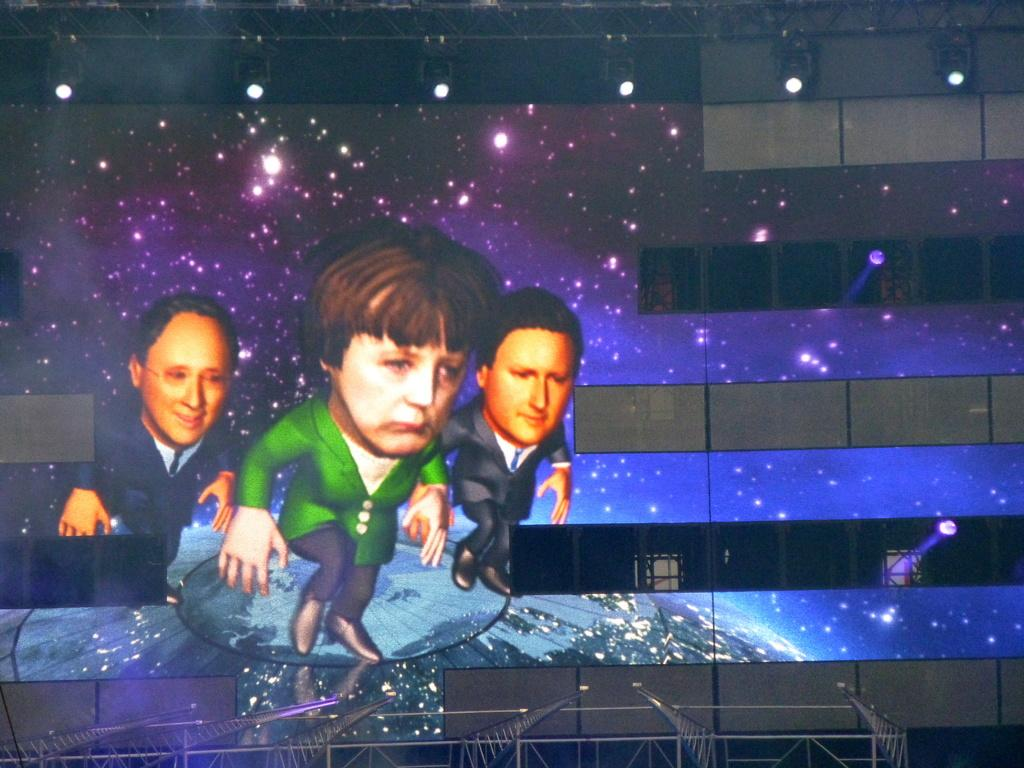How many persons are depicted in the image? There is a depiction ofiction of three persons in the image. What can be seen in the image besides the persons? Multiple lights are visible in the image. What type of structure is present at the bottom of the image? There are iron poles at the bottom of the image. Is there a water fountain visible on the front side of the image? There is no water fountain present in the image, and the terms "front" and "side" are not relevant to the image as it is a two-dimensional depiction. 